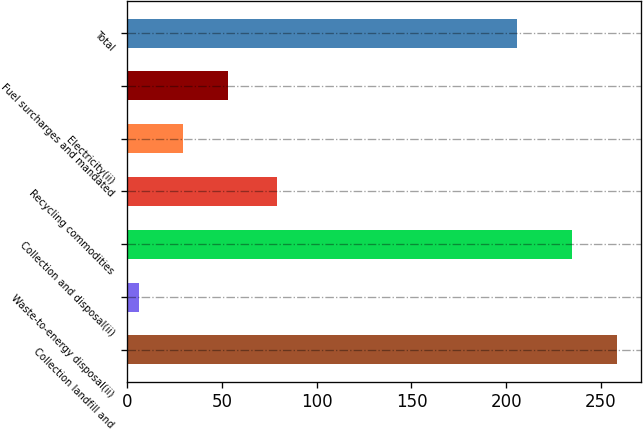Convert chart. <chart><loc_0><loc_0><loc_500><loc_500><bar_chart><fcel>Collection landfill and<fcel>Waste-to-energy disposal(ii)<fcel>Collection and disposal(ii)<fcel>Recycling commodities<fcel>Electricity(ii)<fcel>Fuel surcharges and mandated<fcel>Total<nl><fcel>258.5<fcel>6<fcel>235<fcel>79<fcel>29.5<fcel>53<fcel>206<nl></chart> 